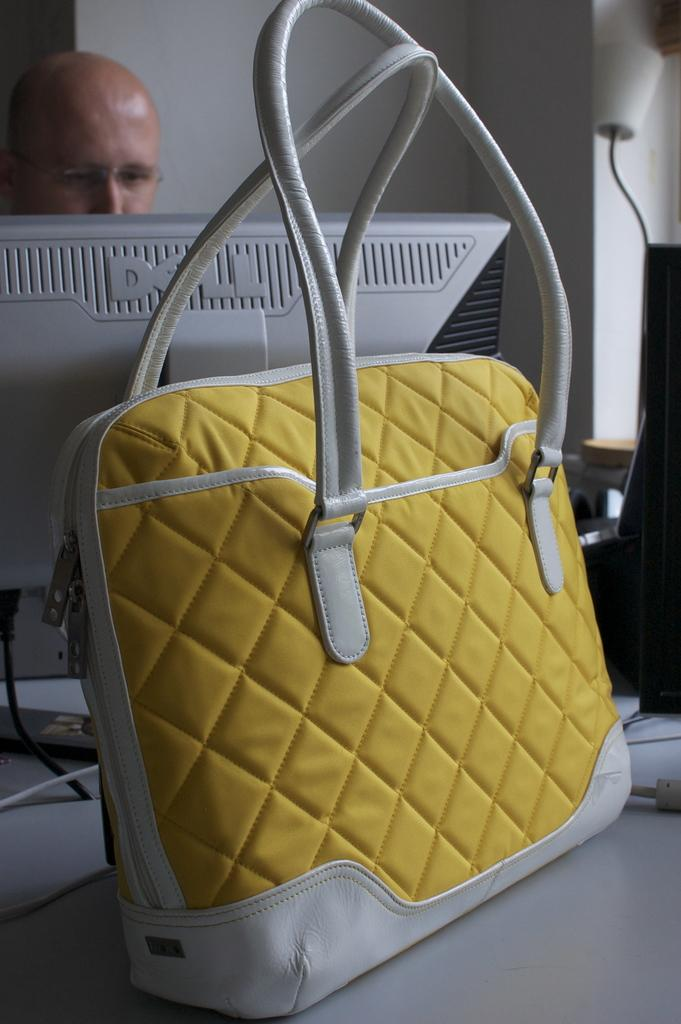Who or what is present in the image? There is a person in the image. What object can be seen in the image that is typically used for eating or working? There is a table in the image. What item is placed on the table in the image? There is a bag on the table. What electronic device is on the table in the image? There is a monitor on the table. What can be seen in the background of the image? There is a wall in the background of the image. What type of tongue can be seen licking the monitor in the image? There is no tongue present in the image, and the monitor is not being licked. 